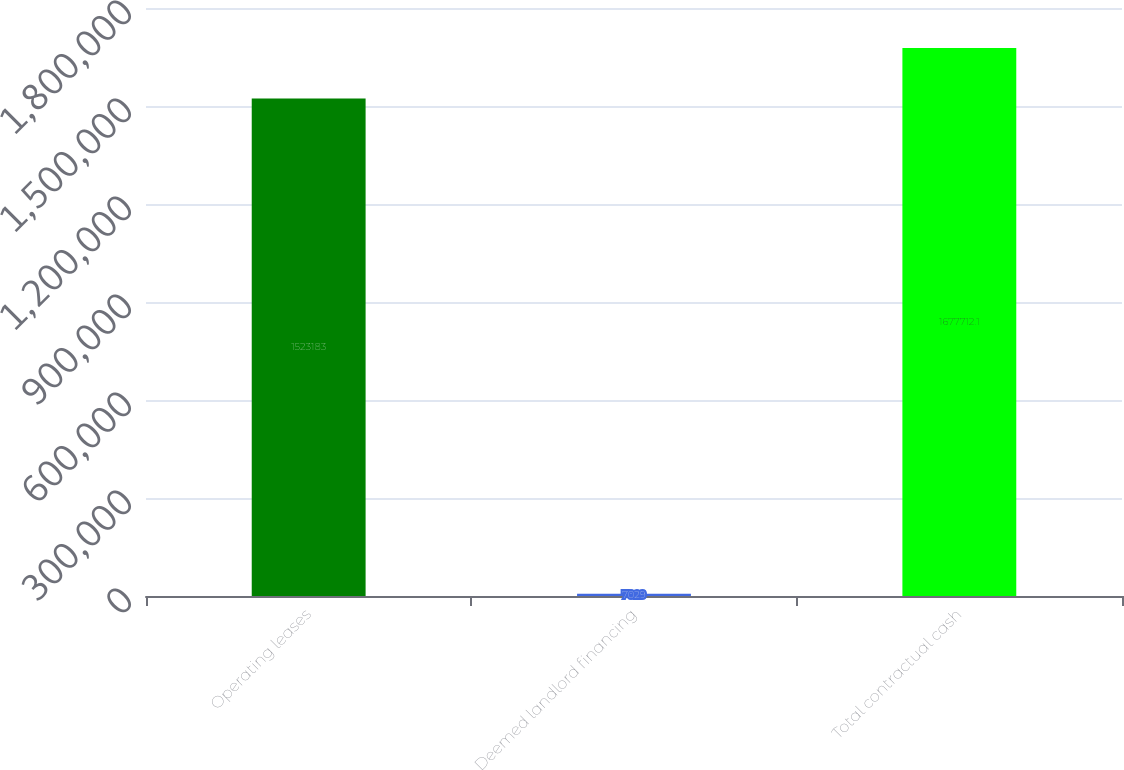<chart> <loc_0><loc_0><loc_500><loc_500><bar_chart><fcel>Operating leases<fcel>Deemed landlord financing<fcel>Total contractual cash<nl><fcel>1.52318e+06<fcel>7029<fcel>1.67771e+06<nl></chart> 